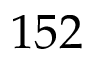<formula> <loc_0><loc_0><loc_500><loc_500>1 5 2</formula> 